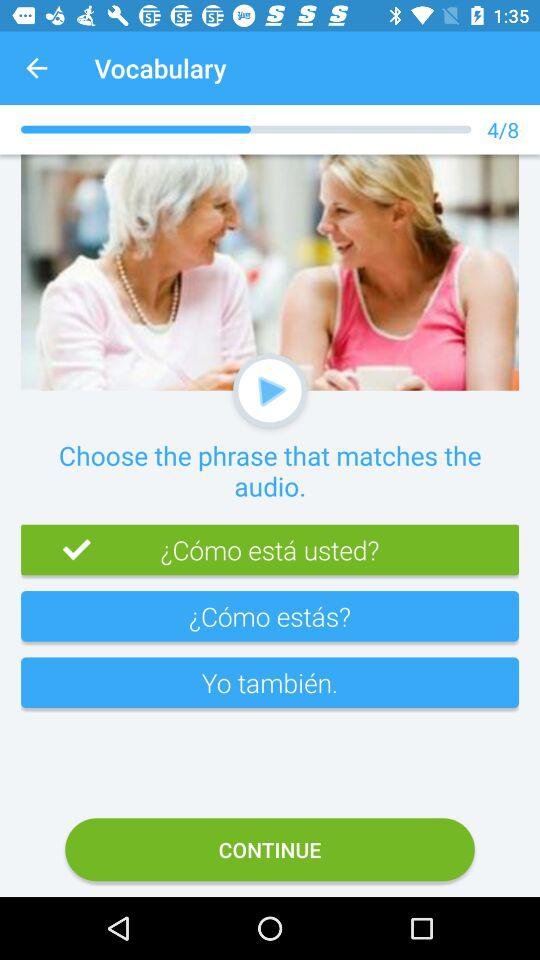How many phrases are there to choose from?
Answer the question using a single word or phrase. 3 